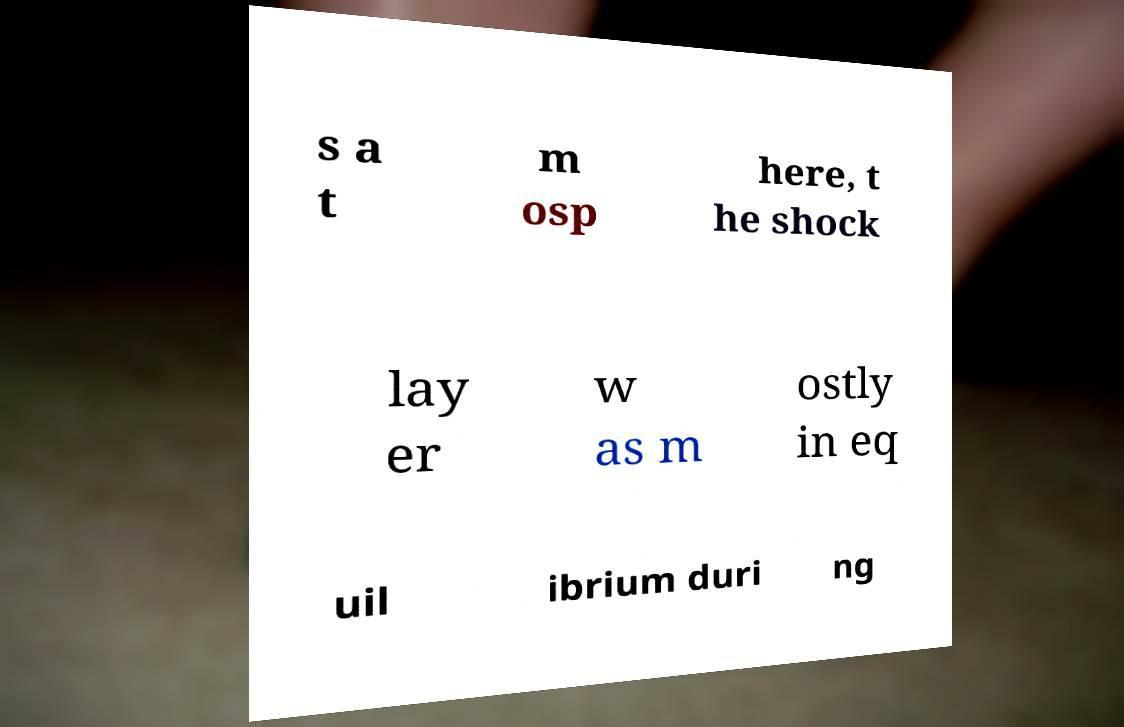Could you assist in decoding the text presented in this image and type it out clearly? s a t m osp here, t he shock lay er w as m ostly in eq uil ibrium duri ng 